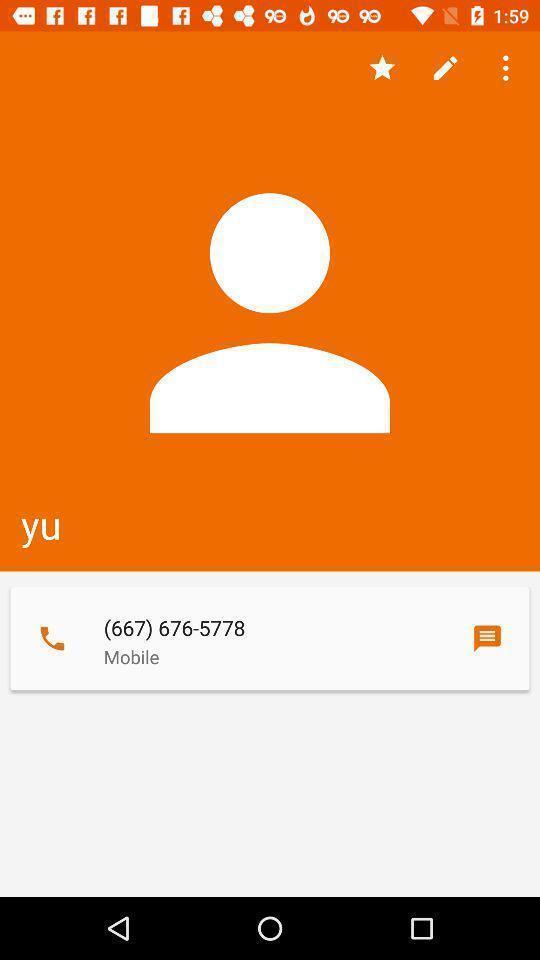Summarize the main components in this picture. Screen page of a contact details. 